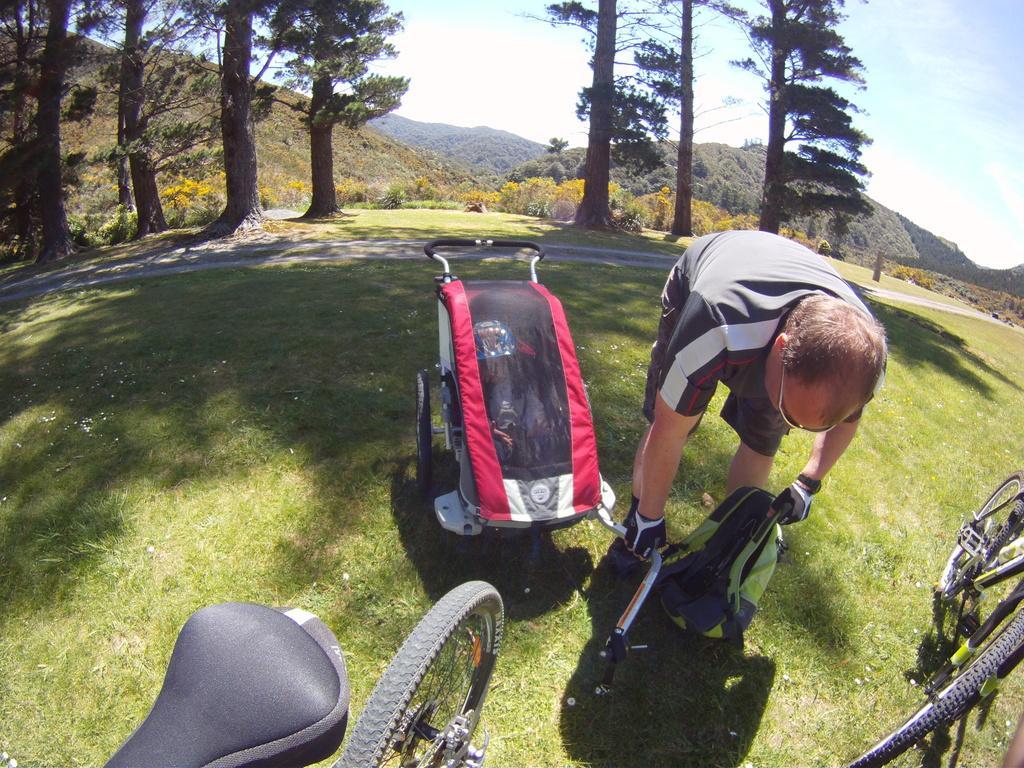How would you summarize this image in a sentence or two? This picture shows a man holding a bag in his hand and we see couple of bicycles and few trees on his back and we see a baby trolley 